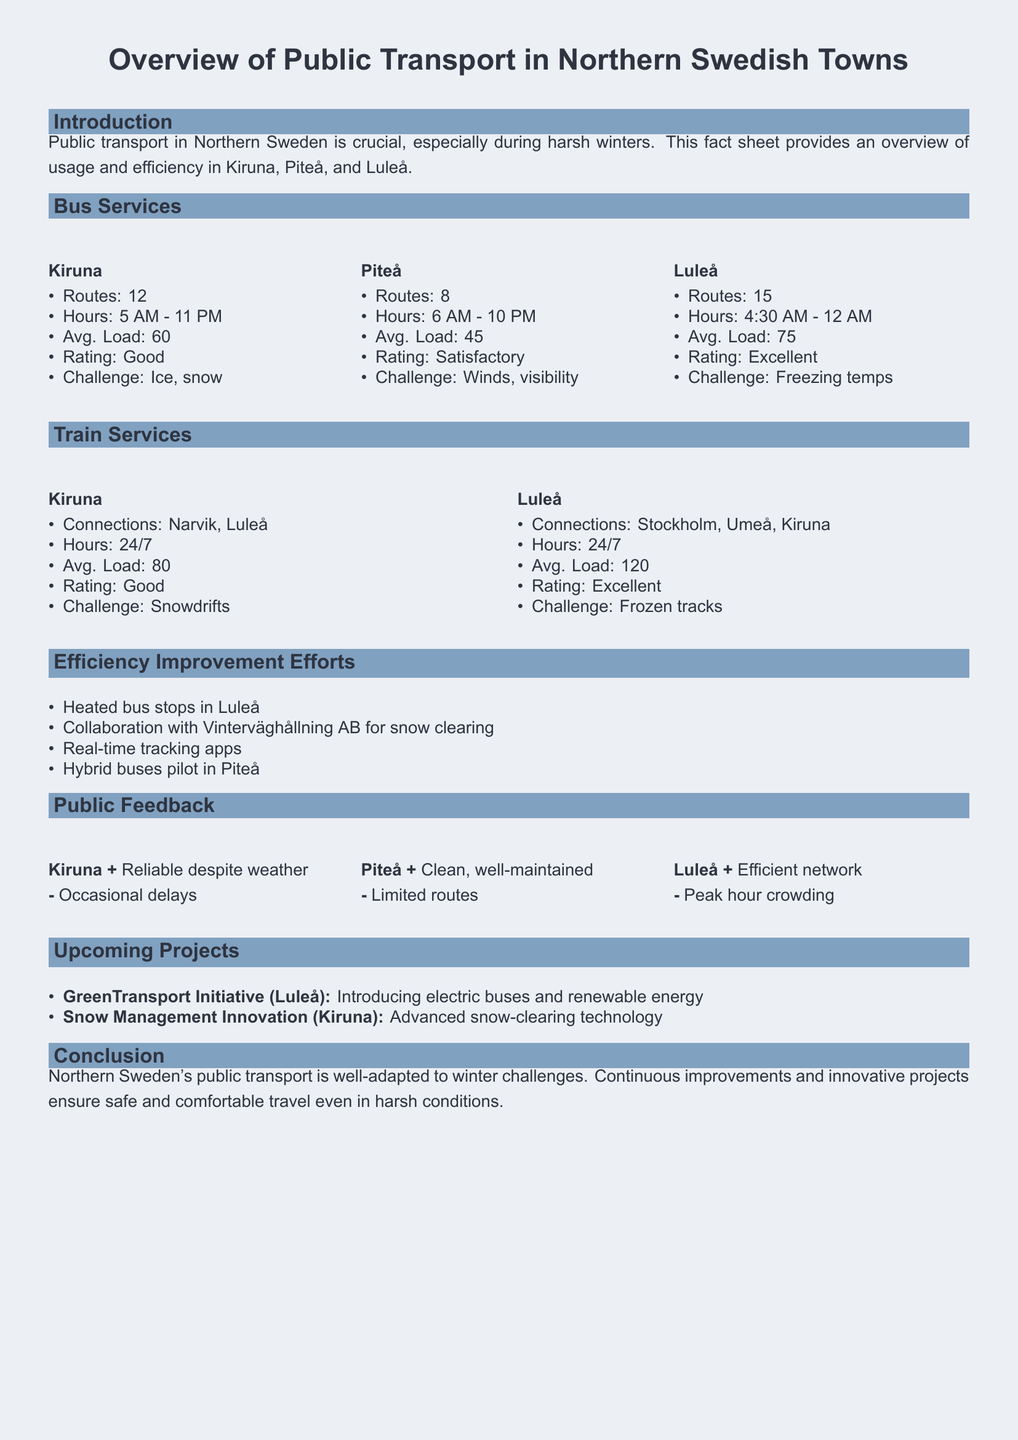What are the operating hours for bus services in Kiruna? The operating hours for bus services in Kiruna are from 5 AM to 11 PM as mentioned in the document.
Answer: 5 AM - 11 PM How many bus routes are available in Piteå? The document states that there are 8 bus routes in Piteå.
Answer: 8 What is the average load for bus services in Luleå? The average load for bus services in Luleå is specified as 75 in the document.
Answer: 75 Which town has a "Good" rating for train services? The document indicates that Kiruna has a "Good" rating for its train services.
Answer: Kiruna What innovative project is planned for Luleå? The document mentions the GreenTransport Initiative, which plans to introduce electric buses and renewable energy.
Answer: GreenTransport Initiative What is a common challenge faced by bus services in Kiruna? The document lists ice and snow as common challenges for bus services in Kiruna.
Answer: Ice, snow What is the average load for train services connecting Luleå? The average load for train services in Luleå is noted to be 120 in the fact sheet.
Answer: 120 Which town provides 24/7 train services? The fact sheet states that both Kiruna and Luleå offer 24/7 train services.
Answer: Kiruna, Luleå What is the user feedback regarding bus services in Piteå? The feedback from users in Piteå indicates that the services are clean and well-maintained, but have limited routes.
Answer: Clean, well-maintained; Limited routes 